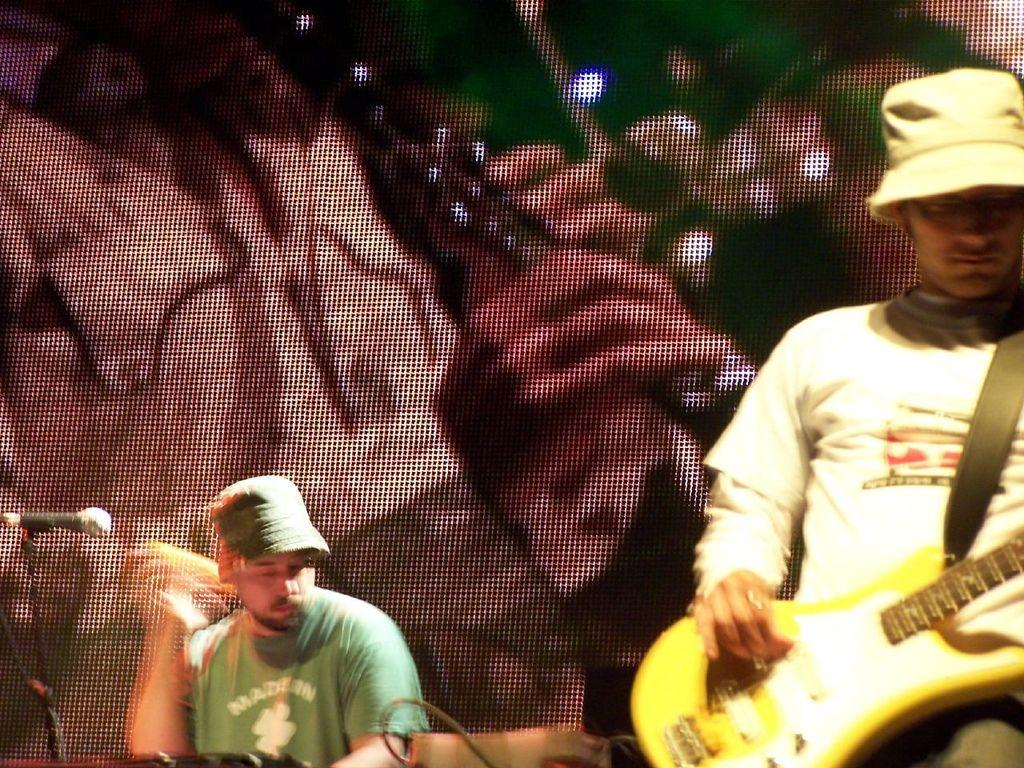What is the main activity taking place in the image? There is a man playing a guitar in the image. Can you describe the position of the man playing the guitar? The man playing the guitar is in the front. What other musical instrument can be seen in the image? There is another man playing drums in the image. How is the man playing drums positioned in relation to the man playing the guitar? The man playing drums is in the background. How many cows are visible in the image? There are no cows present in the image. What route is the boy taking in the image? There is no boy present in the image. 